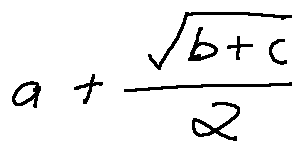Convert formula to latex. <formula><loc_0><loc_0><loc_500><loc_500>a + \frac { \sqrt { b + c } } { 2 }</formula> 